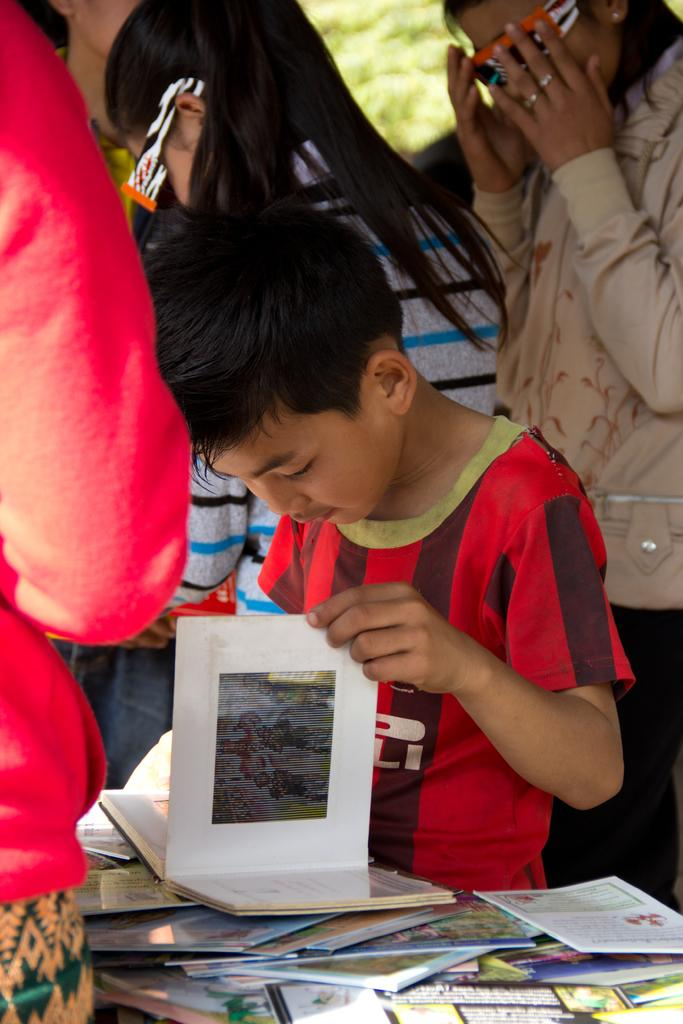Who is present in the image? There are people in the image. Can you describe the boy in the image? The boy is in the middle of the image, and he is holding a book. What else can be seen near the boy? There are additional books in front of the boy. What type of prison is visible in the background of the image? There is no prison present in the image; it features people, a boy, and books. What appliance is being used by the boy to read the book? The boy is holding a book, and there is no appliance involved in reading the book in the image. 